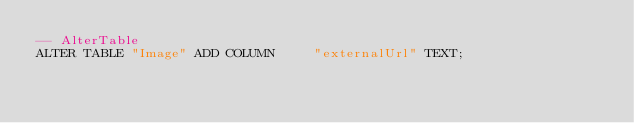<code> <loc_0><loc_0><loc_500><loc_500><_SQL_>-- AlterTable
ALTER TABLE "Image" ADD COLUMN     "externalUrl" TEXT;
</code> 